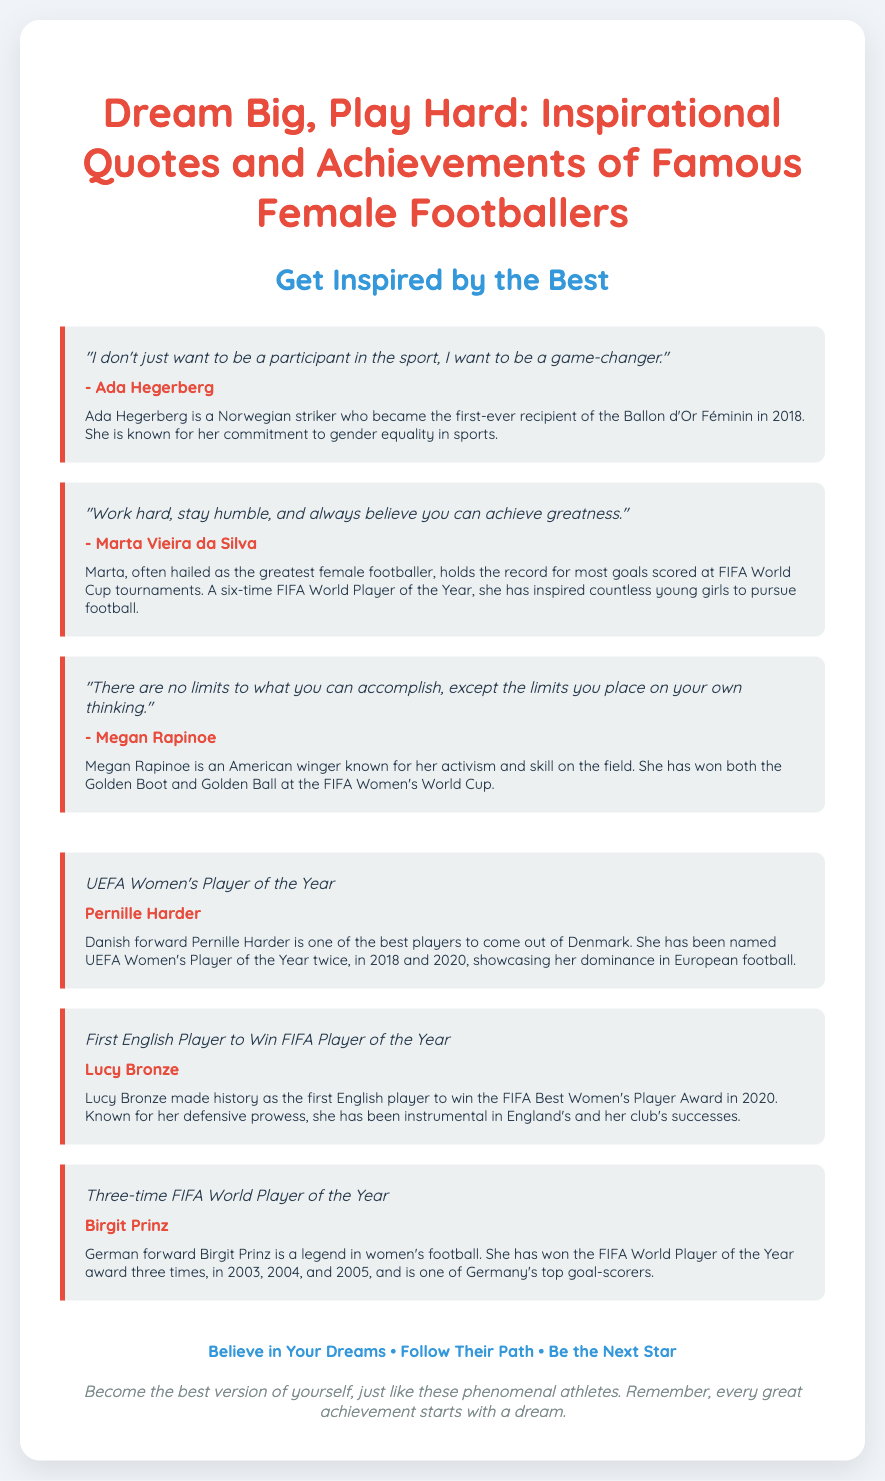What does Ada Hegerberg aspire to be in football? Ada Hegerberg expresses her desire to be a game-changer in the sport.
Answer: game-changer How many times has Pernille Harder been named UEFA Women's Player of the Year? The document states that Pernille Harder has been named UEFA Women's Player of the Year twice.
Answer: twice What record does Marta hold at FIFA World Cup tournaments? Marta holds the record for most goals scored at FIFA World Cup tournaments.
Answer: most goals Which award did Lucy Bronze win in 2020? Lucy Bronze made history as the first English player to win the FIFA Best Women's Player Award in 2020.
Answer: FIFA Best Women's Player Award What is the inspirational message at the bottom of the poster? The footer emphasizes believing in dreams and following the path of phenomenal athletes to become the next star.
Answer: Believe in Your Dreams • Follow Their Path • Be the Next Star Who is known for her activism and skill on the field? The document highlights Megan Rapinoe as an American winger known for her activism and skill.
Answer: Megan Rapinoe In what year did Ada Hegerberg receive the Ballon d'Or Féminin? Ada Hegerberg is recognized as the first-ever recipient of the Ballon d'Or Féminin in 2018.
Answer: 2018 How many times did Birgit Prinz win the FIFA World Player of the Year award? Birgit Prinz has won the FIFA World Player of the Year award three times.
Answer: three times What is a common theme across the quotes shared on the poster? The quotes emphasize hard work, belief in oneself, and striving for greatness in football.
Answer: hard work, belief, greatness 